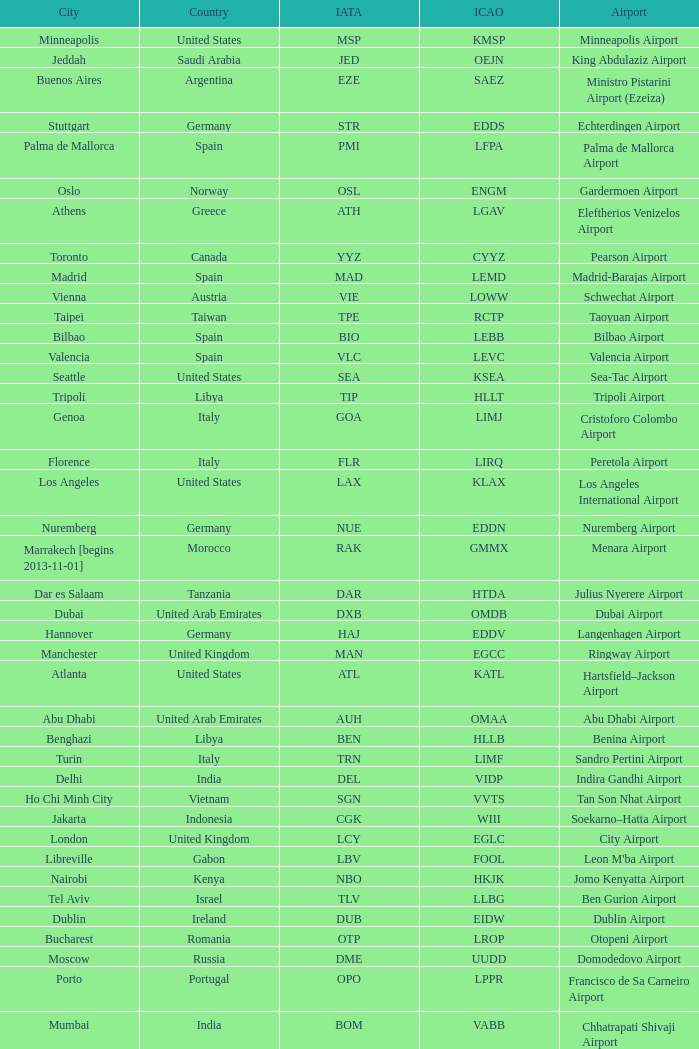What is the ICAO of Lohausen airport? EDDL. 